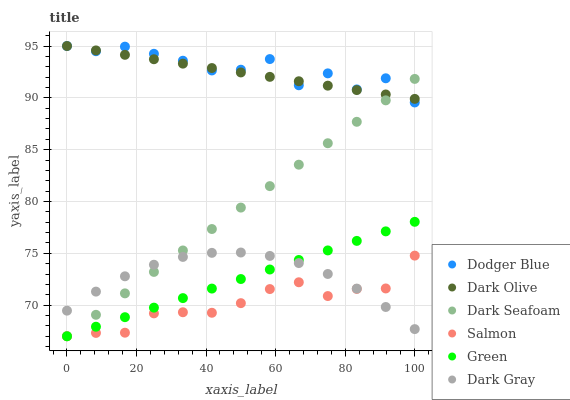Does Salmon have the minimum area under the curve?
Answer yes or no. Yes. Does Dodger Blue have the maximum area under the curve?
Answer yes or no. Yes. Does Dark Gray have the minimum area under the curve?
Answer yes or no. No. Does Dark Gray have the maximum area under the curve?
Answer yes or no. No. Is Dark Seafoam the smoothest?
Answer yes or no. Yes. Is Dodger Blue the roughest?
Answer yes or no. Yes. Is Salmon the smoothest?
Answer yes or no. No. Is Salmon the roughest?
Answer yes or no. No. Does Salmon have the lowest value?
Answer yes or no. Yes. Does Dark Gray have the lowest value?
Answer yes or no. No. Does Dodger Blue have the highest value?
Answer yes or no. Yes. Does Dark Gray have the highest value?
Answer yes or no. No. Is Salmon less than Dodger Blue?
Answer yes or no. Yes. Is Dark Olive greater than Salmon?
Answer yes or no. Yes. Does Salmon intersect Dark Gray?
Answer yes or no. Yes. Is Salmon less than Dark Gray?
Answer yes or no. No. Is Salmon greater than Dark Gray?
Answer yes or no. No. Does Salmon intersect Dodger Blue?
Answer yes or no. No. 